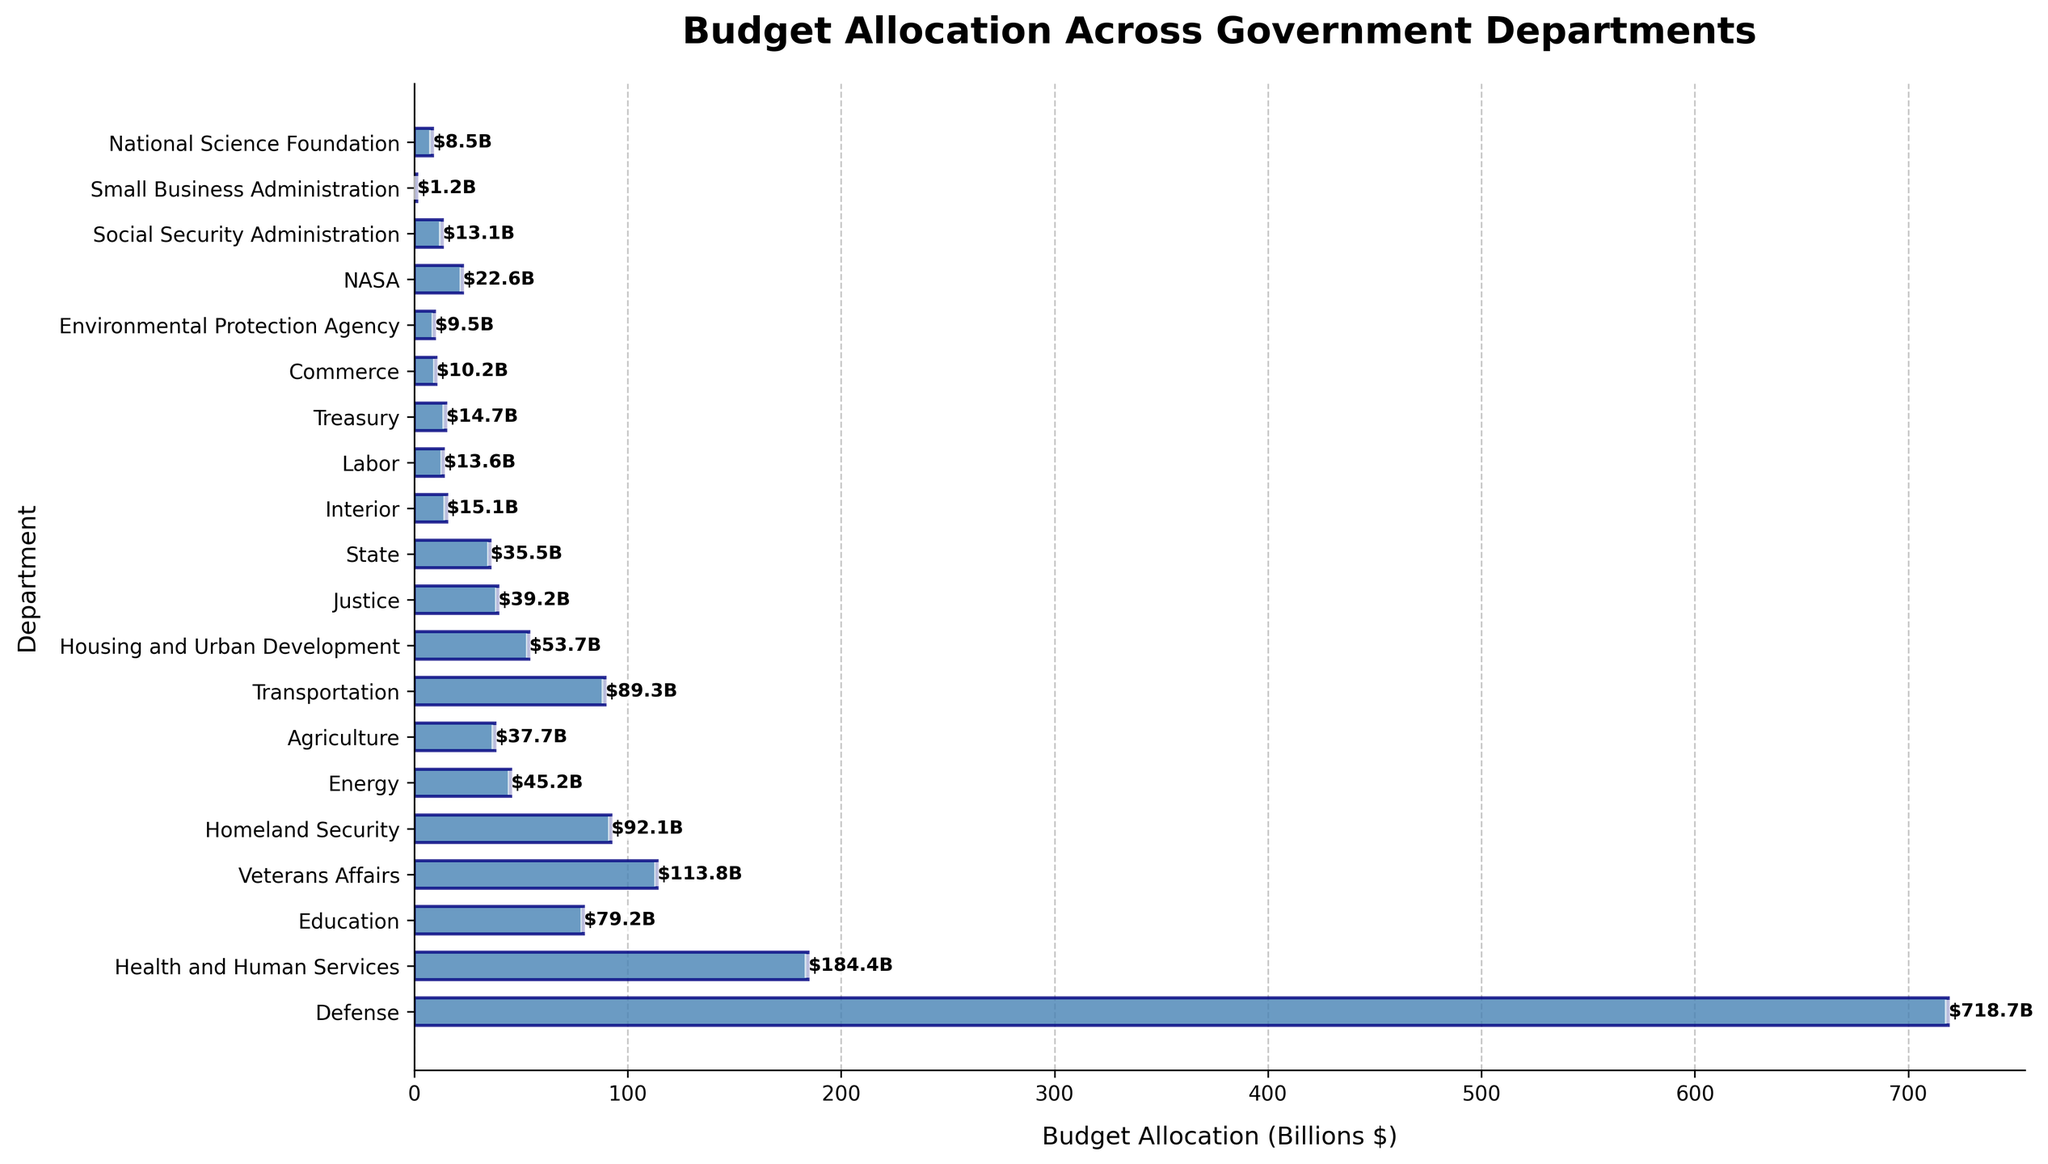What is the total budget allocation for the Defense and Health and Human Services departments? Add the budget allocation for the Defense department ($718.69B) to the budget allocation for the Health and Human Services department ($184.42B). Total = $718.69B + $184.42B = $903.11B.
Answer: $903.11B Which department has the highest budget allocation, and what is its value? Identify the department with the longest bar in the bar chart, which represents the highest budget allocation. The Defense department has the longest bar with a budget allocation of $718.69B.
Answer: Defense, $718.69B Which department has the lowest budget allocation, and what is its value? Identify the department with the shortest bar in the bar chart, which represents the lowest budget allocation. The Small Business Administration has the shortest bar with a budget allocation of $1.2B.
Answer: Small Business Administration, $1.2B How much more is allocated to the Department of Veterans Affairs compared to the Department of Education? Subtract the budget allocation of the Department of Education ($79.2B) from the budget allocation of the Department of Veterans Affairs ($113.8B). Difference = $113.8B - $79.2B = $34.6B.
Answer: $34.6B What is the combined budget allocation for the departments of Homeland Security, Energy, and Agriculture? Add the budget allocations for Homeland Security ($92.1B), Energy ($45.2B), and Agriculture ($37.7B). Total = $92.1B + $45.2B + $37.7B = $175B.
Answer: $175B Which department has a budget closest to $50 billion, and what is its exact budget? Identify the bar whose labeled budget value is closest to $50 billion. The Housing and Urban Development department has a budget allocation closest to $50 billion with an exact budget of $53.7B.
Answer: Housing and Urban Development, $53.7B How does the budget allocation for NASA compare to that for the Department of Justice? Compare the lengths of the bars for NASA and the Department of Justice. The budget allocation for NASA ($22.6B) is less than that for the Department of Justice ($39.2B).
Answer: NASA's budget is less than the Department of Justice's budget What is the average budget allocation for the listed government departments? Sum the budget allocations for all the listed departments and divide by the number of departments (20). Total budget = $1,517.86B. Average = $1,517.86B / 20 = $75.89B.
Answer: $75.89B Is the budget allocation for the Social Security Administration greater than or less than that of the Environmental Protection Agency? Compare the lengths of the bars for the Social Security Administration and the Environmental Protection Agency. The budget allocation for the Social Security Administration ($13.1B) is greater than that for the Environmental Protection Agency ($9.5B).
Answer: Greater 